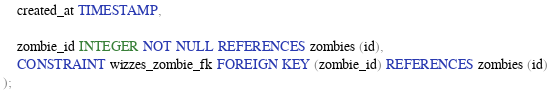<code> <loc_0><loc_0><loc_500><loc_500><_SQL_>    created_at TIMESTAMP,

    zombie_id INTEGER NOT NULL REFERENCES zombies (id),
    CONSTRAINT wizzes_zombie_fk FOREIGN KEY (zombie_id) REFERENCES zombies (id)
);
</code> 